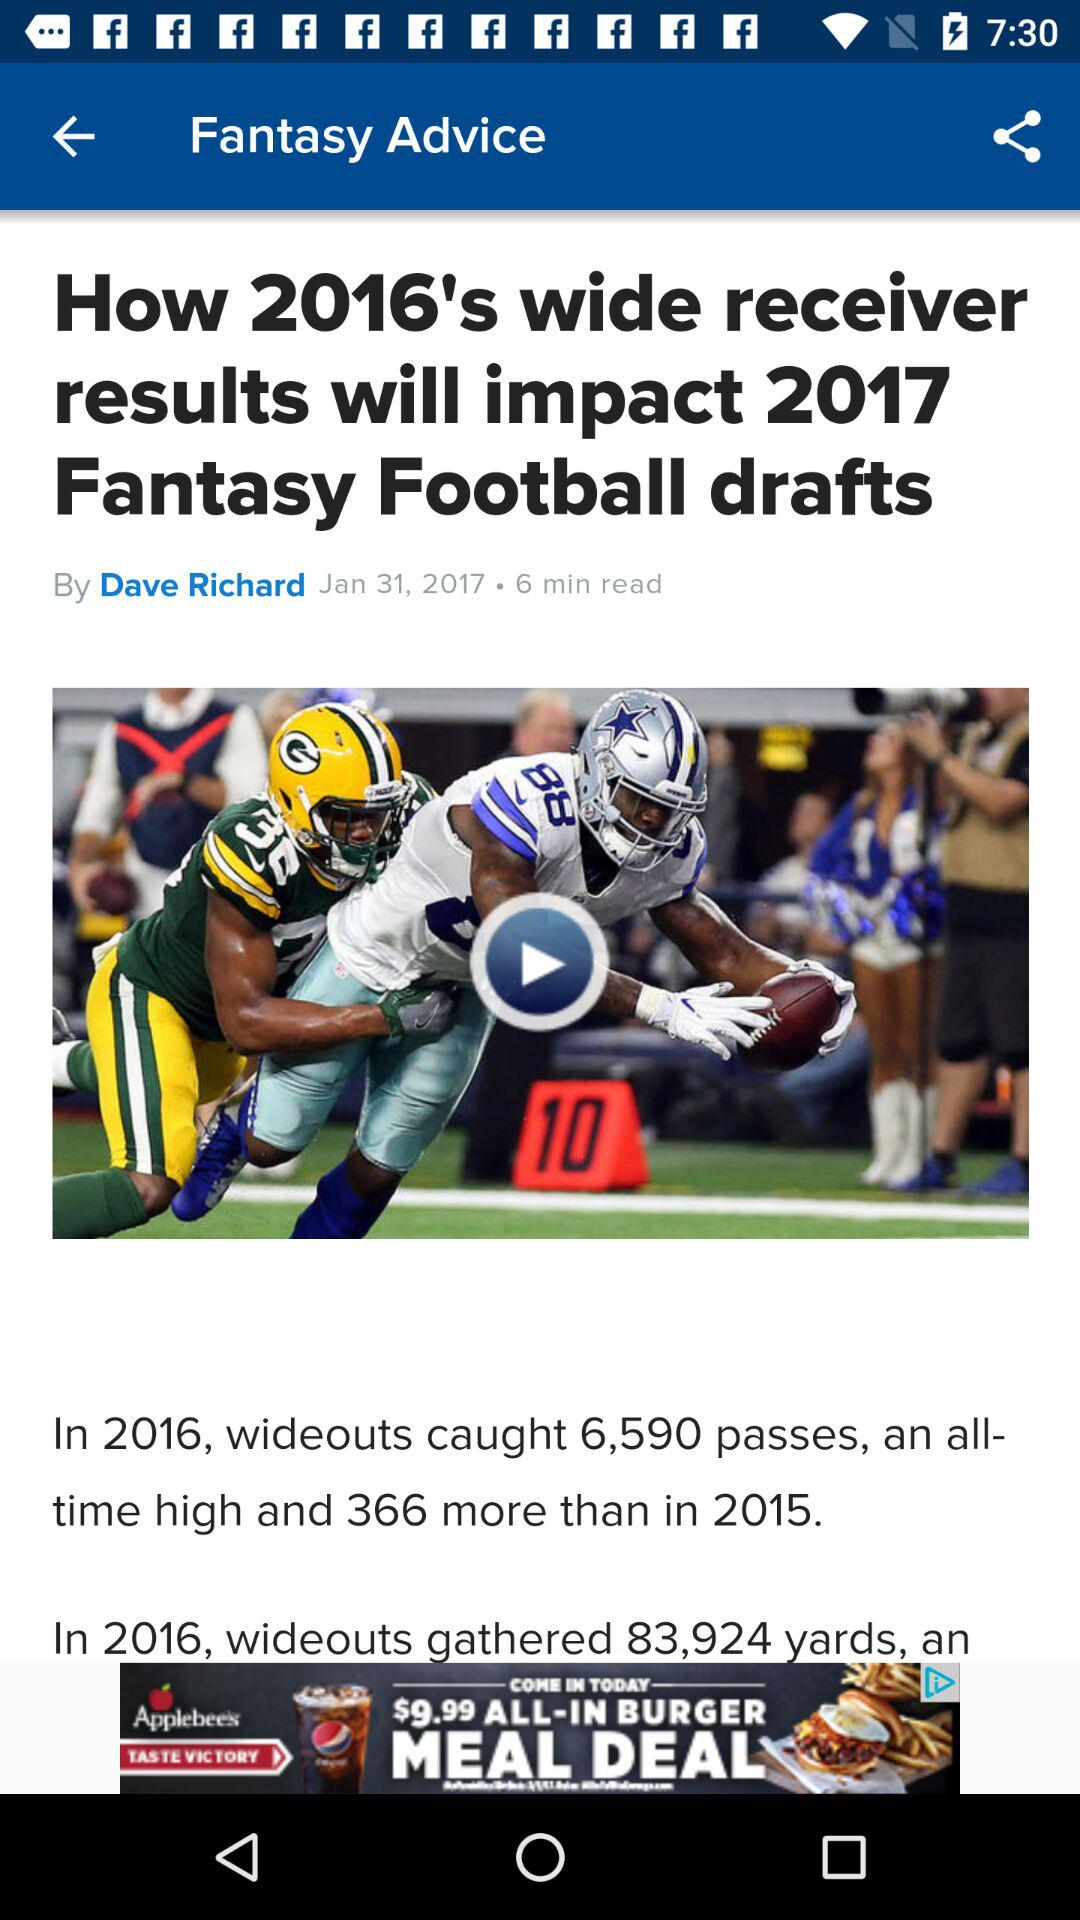How many more passes did wideouts catch in 2016 than in 2015? In the 2016 NFL season, wide receivers made a remarkable catch total of 6,590 passes. This is an impressive increase of 366 passes compared to the tally from 2015, showcasing a significant boost in receiving performance during that year. 